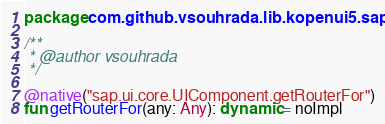<code> <loc_0><loc_0><loc_500><loc_500><_Kotlin_>package com.github.vsouhrada.lib.kopenui5.sap

/**
 * @author vsouhrada
 */

@native("sap.ui.core.UIComponent.getRouterFor")
fun getRouterFor(any: Any): dynamic = noImpl
</code> 